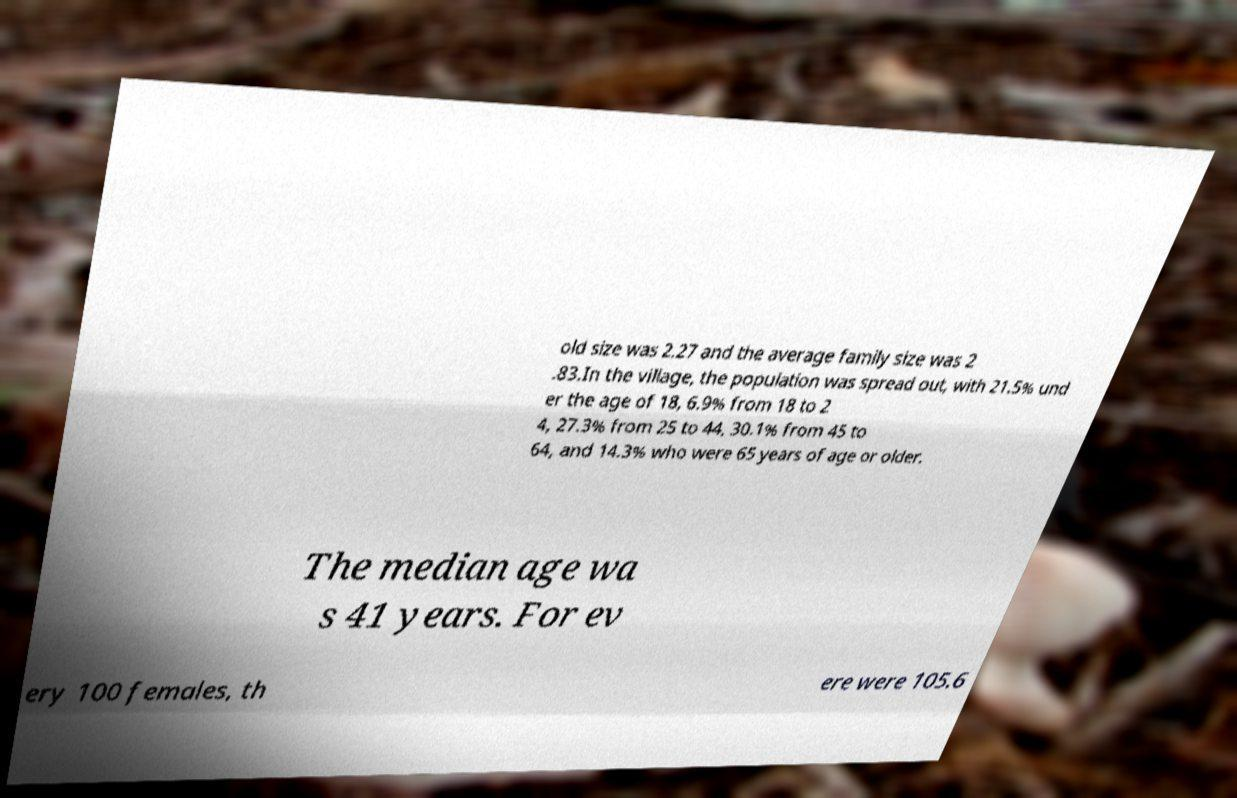Please identify and transcribe the text found in this image. old size was 2.27 and the average family size was 2 .83.In the village, the population was spread out, with 21.5% und er the age of 18, 6.9% from 18 to 2 4, 27.3% from 25 to 44, 30.1% from 45 to 64, and 14.3% who were 65 years of age or older. The median age wa s 41 years. For ev ery 100 females, th ere were 105.6 